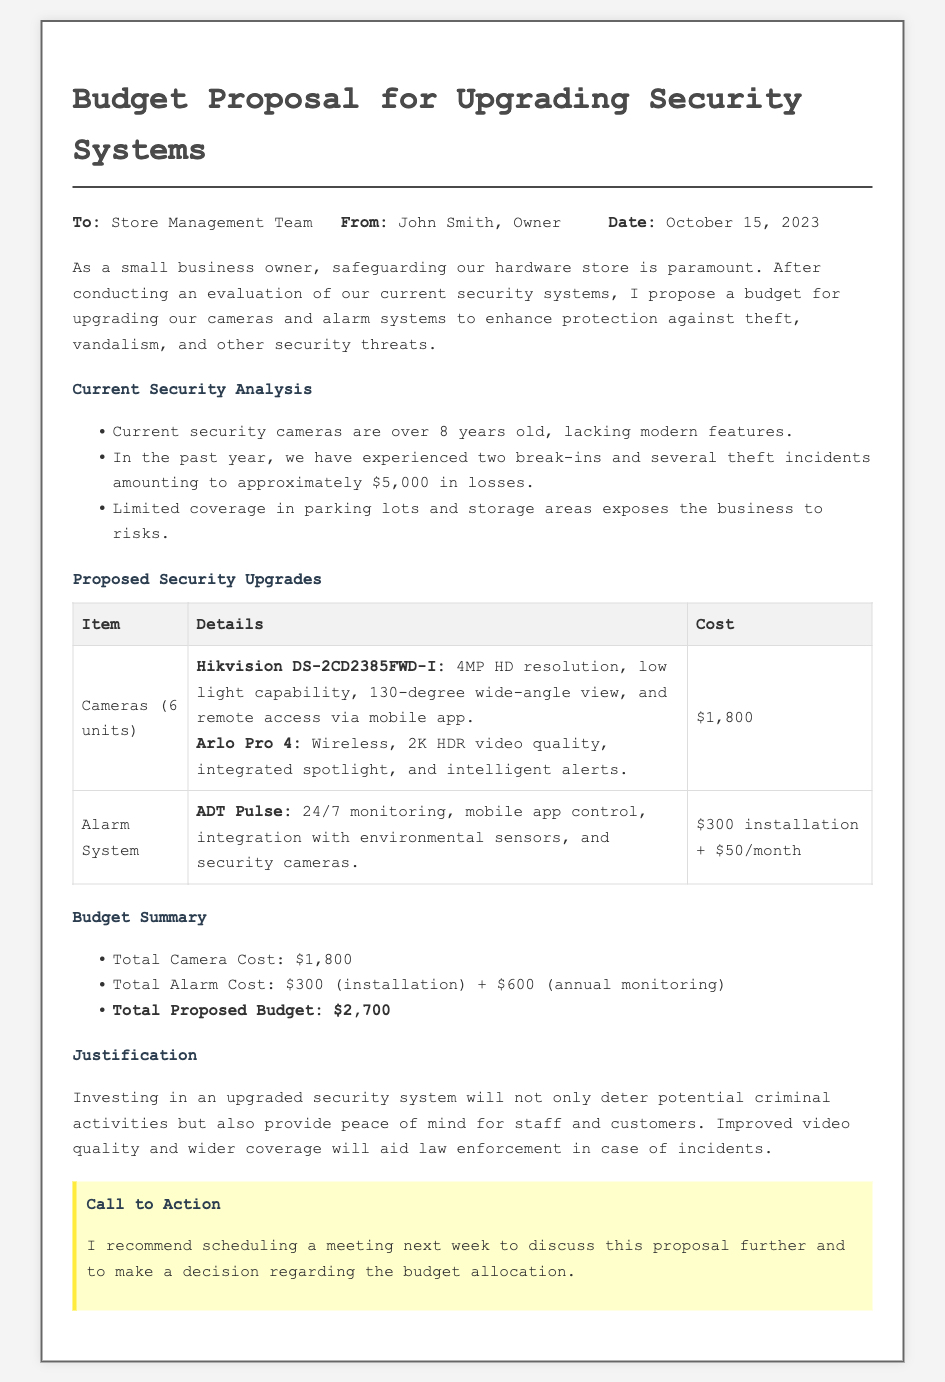what is the date of the memo? The date of the memo is clearly mentioned in the header section, which is October 15, 2023.
Answer: October 15, 2023 who is the author of the memo? The author of the memo is identified in the header section, with the name John Smith.
Answer: John Smith how many camera units are proposed for purchase? The proposed number of camera units is stated in the section about proposed upgrades, which lists 6 units.
Answer: 6 units what is the total proposed budget for the upgrades? The total proposed budget is detailed in the budget summary section, which lists the total as $2,700.
Answer: $2,700 what type of alarm system is proposed? The specific alarm system recommended is mentioned in the proposed security upgrades section, identified as ADT Pulse.
Answer: ADT Pulse how much has the store lost to theft incidents in the past year? The losses from theft incidents are stated in the current security analysis, which mentions approximately $5,000 in losses.
Answer: $5,000 what is the installation cost for the alarm system? The installation cost for the alarm system is detailed in the proposed upgrades section, which specifies $300.
Answer: $300 why is there a need for upgrading the security system? The justification section mentions the need to deter criminal activities and provide peace of mind, summarizing the importance of an upgraded security system.
Answer: Deter criminal activities what is the monthly cost for monitoring the alarm system? The monthly cost for monitoring the alarm system is specified as $50 per month in the proposed upgrades section.
Answer: $50/month 